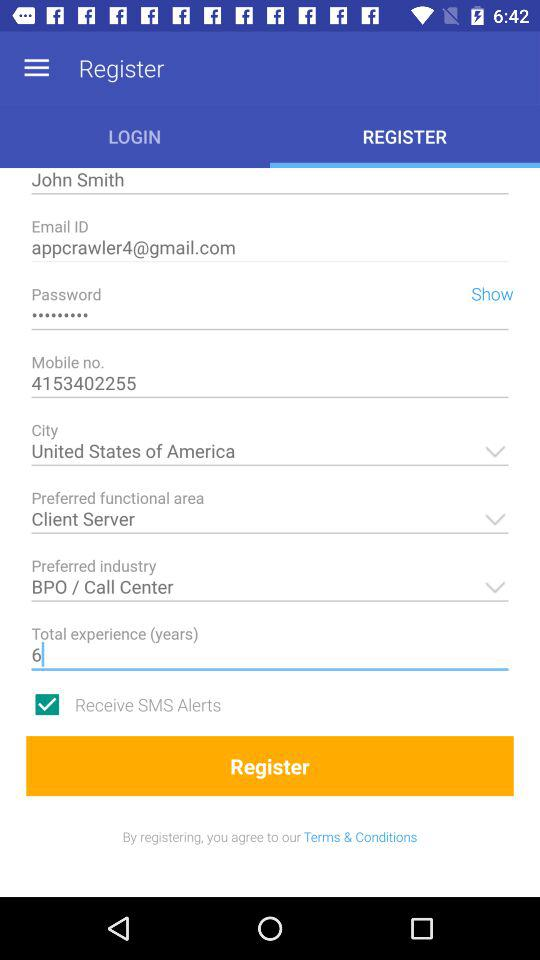What is the name? The name is John Smith. 